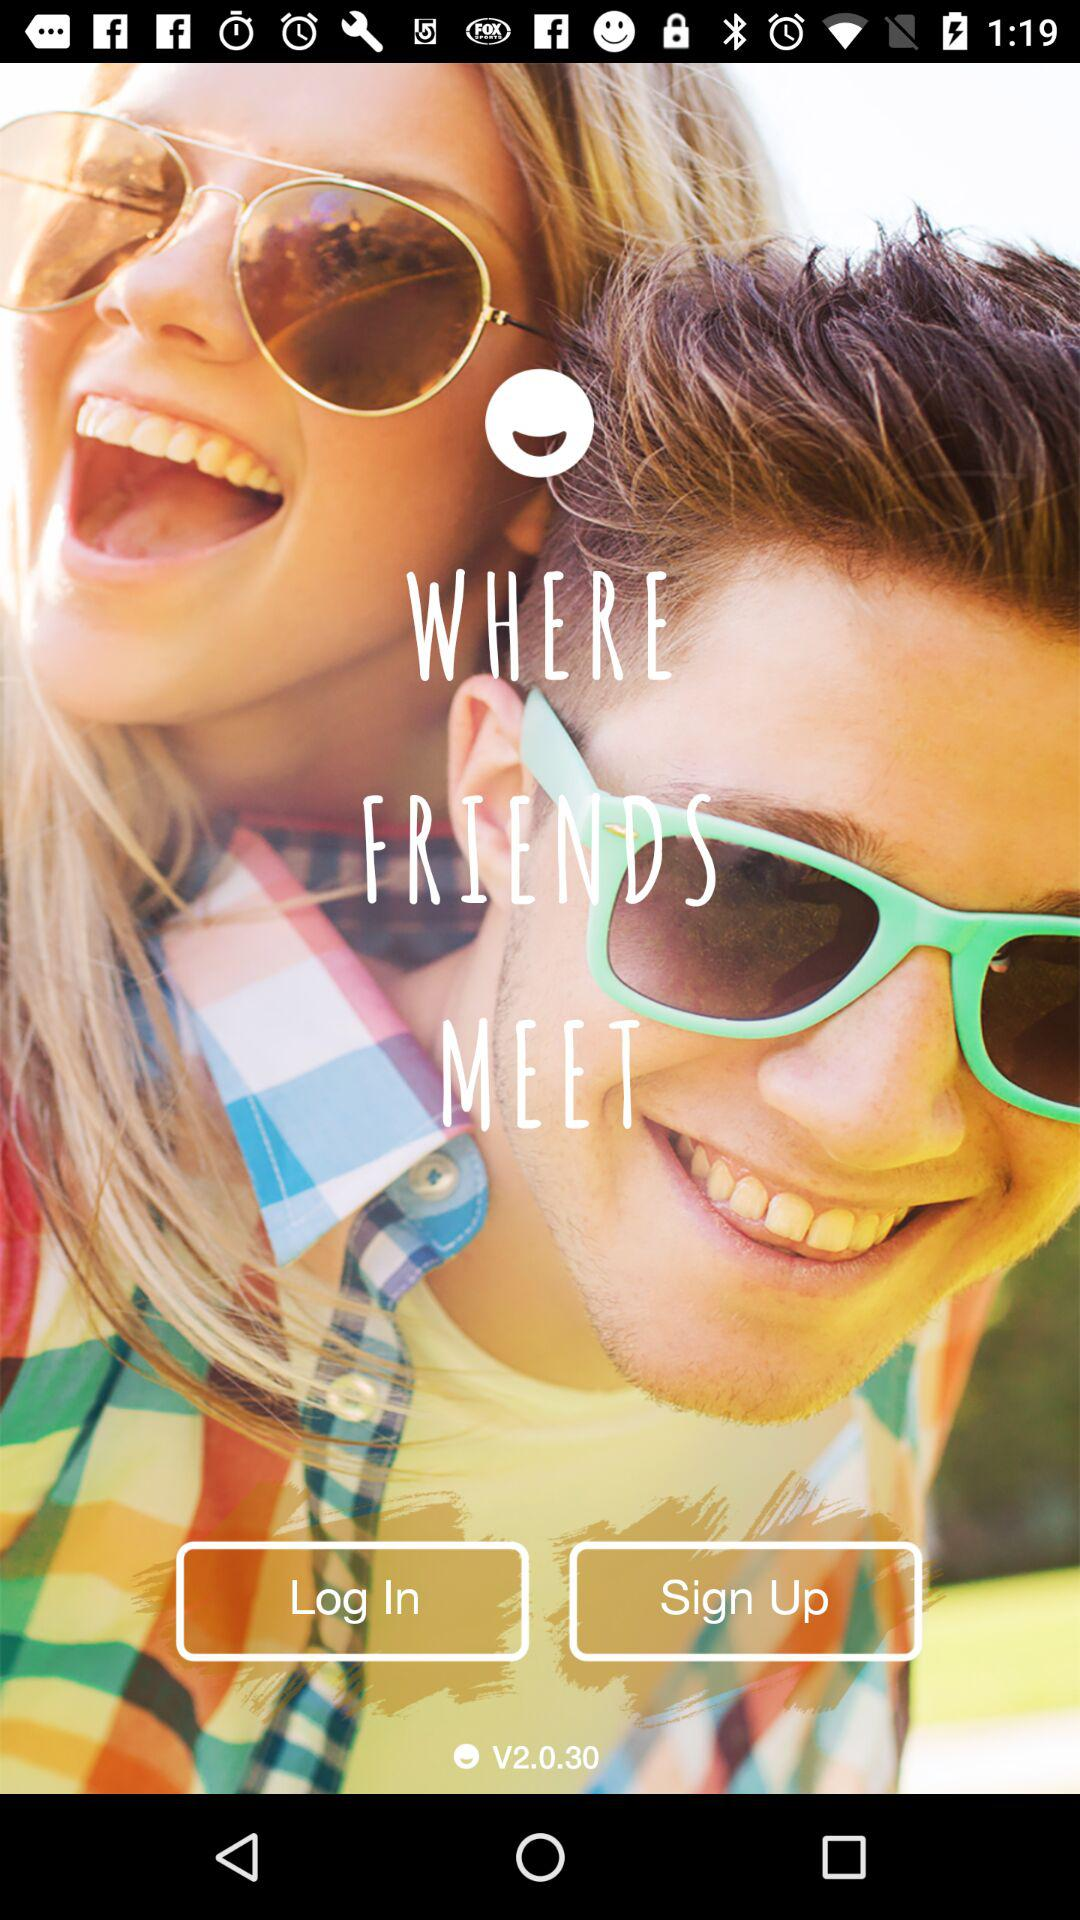What is the version of the application being used? The version of the application being used is V2.0.30. 